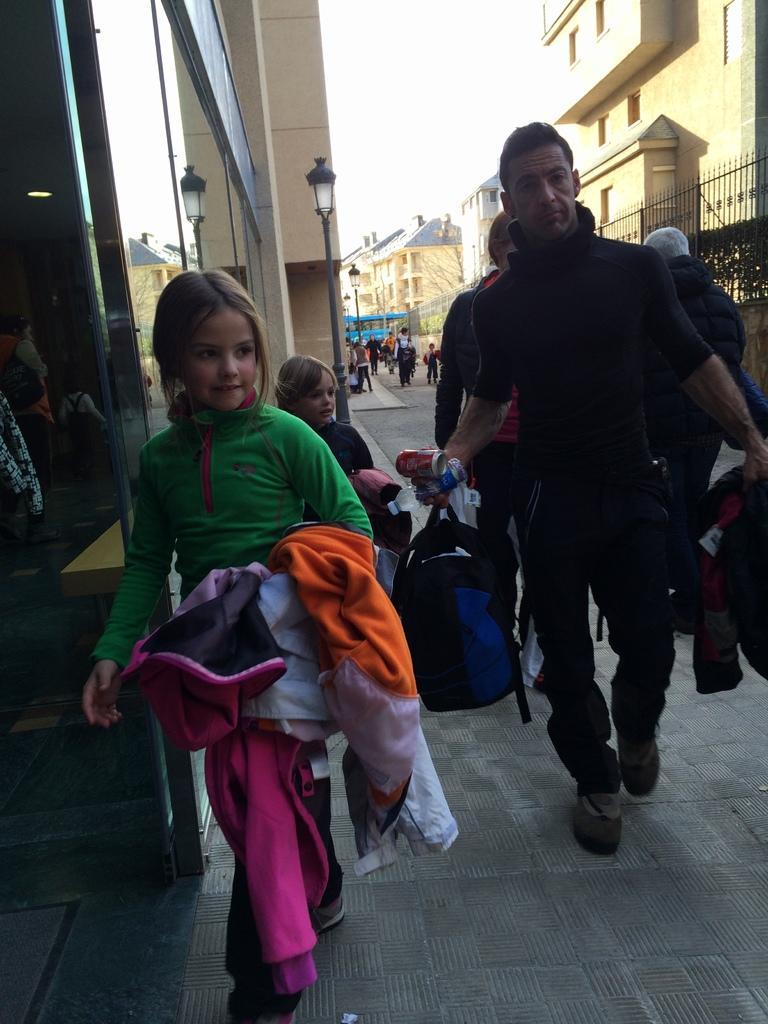How would you summarize this image in a sentence or two? The picture is taken outside a city. In the foreground of the picture there are kids and people. On the left there are buildings, street light and people. In the background there are buildings, street light, fencing, trees, vehicle and people walking down the road. Sky is sunny. 